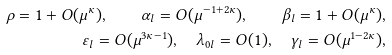Convert formula to latex. <formula><loc_0><loc_0><loc_500><loc_500>\rho = 1 + O ( \mu ^ { \kappa } ) , \quad \alpha _ { l } = O ( \mu ^ { - 1 + 2 \kappa } ) , \quad \beta _ { l } = 1 + O ( \mu ^ { \kappa } ) , \\ \varepsilon _ { l } = O ( \mu ^ { 3 \kappa - 1 } ) , \quad \lambda _ { 0 l } = O ( 1 ) , \quad \gamma _ { l } = O ( \mu ^ { 1 - 2 \kappa } ) ,</formula> 